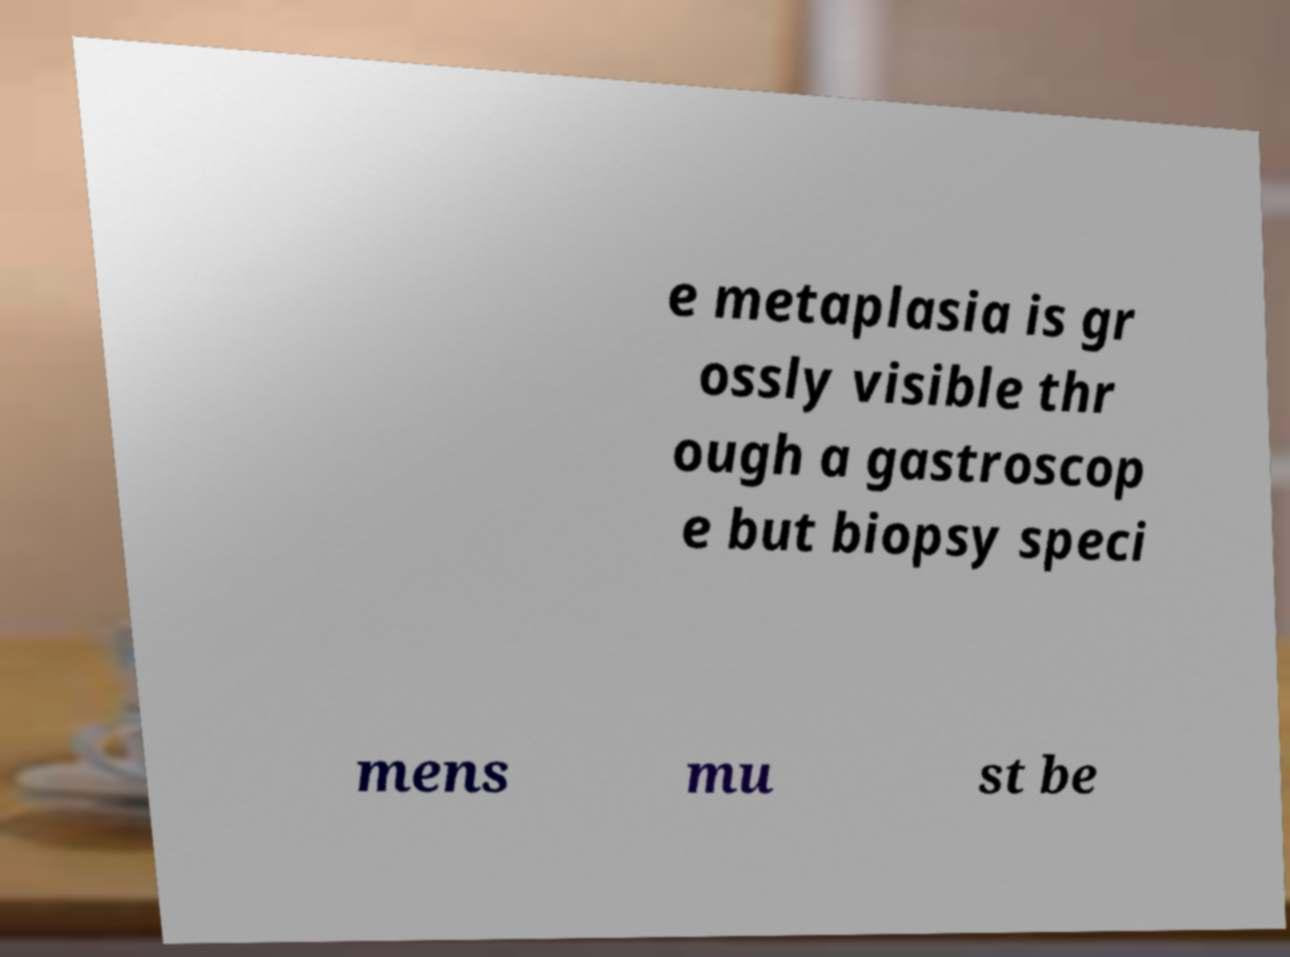Can you read and provide the text displayed in the image?This photo seems to have some interesting text. Can you extract and type it out for me? e metaplasia is gr ossly visible thr ough a gastroscop e but biopsy speci mens mu st be 